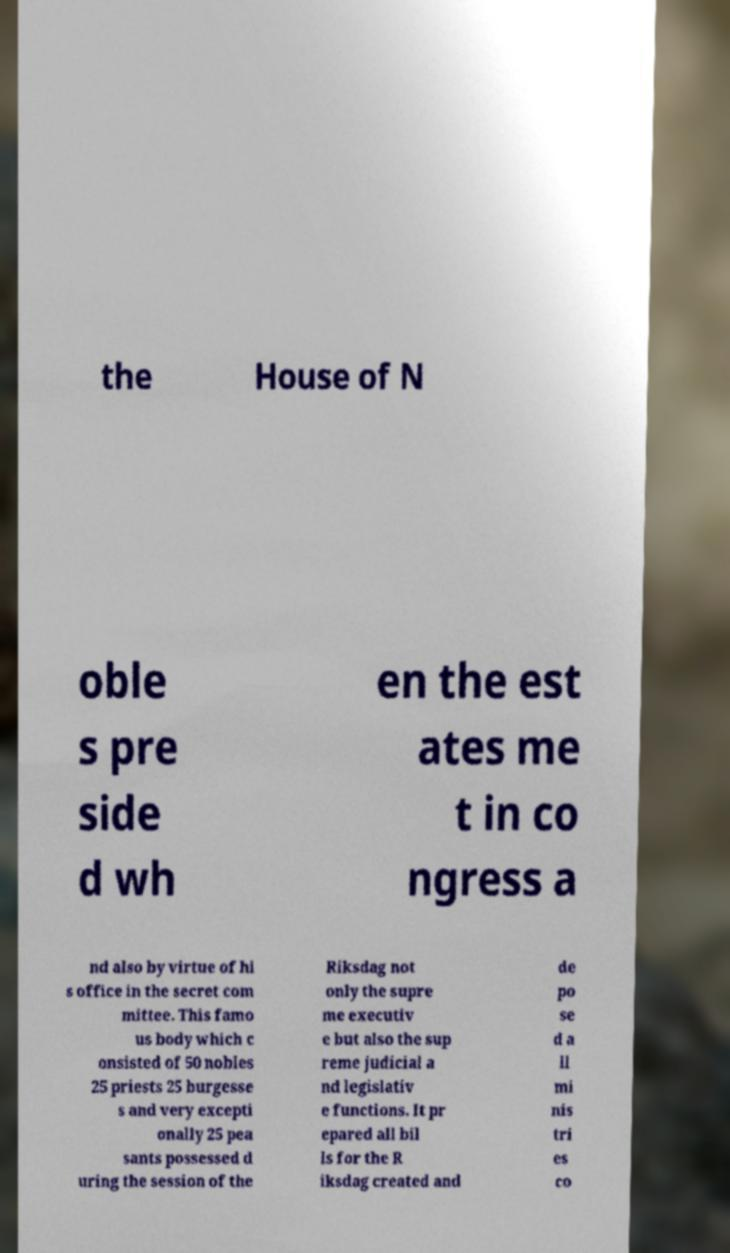I need the written content from this picture converted into text. Can you do that? the House of N oble s pre side d wh en the est ates me t in co ngress a nd also by virtue of hi s office in the secret com mittee. This famo us body which c onsisted of 50 nobles 25 priests 25 burgesse s and very excepti onally 25 pea sants possessed d uring the session of the Riksdag not only the supre me executiv e but also the sup reme judicial a nd legislativ e functions. It pr epared all bil ls for the R iksdag created and de po se d a ll mi nis tri es co 